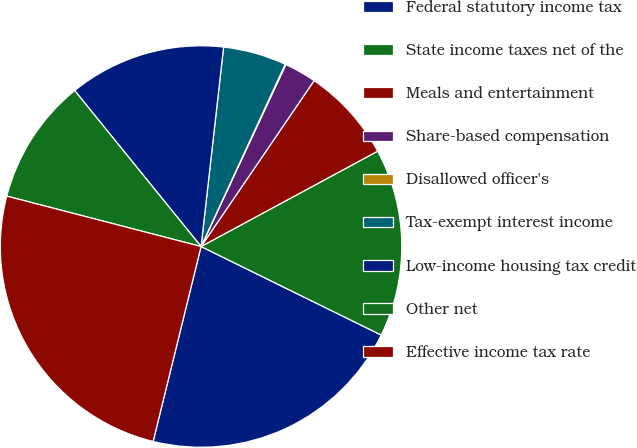<chart> <loc_0><loc_0><loc_500><loc_500><pie_chart><fcel>Federal statutory income tax<fcel>State income taxes net of the<fcel>Meals and entertainment<fcel>Share-based compensation<fcel>Disallowed officer's<fcel>Tax-exempt interest income<fcel>Low-income housing tax credit<fcel>Other net<fcel>Effective income tax rate<nl><fcel>21.57%<fcel>15.15%<fcel>7.6%<fcel>2.58%<fcel>0.06%<fcel>5.09%<fcel>12.63%<fcel>10.12%<fcel>25.2%<nl></chart> 